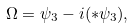Convert formula to latex. <formula><loc_0><loc_0><loc_500><loc_500>\Omega = \psi _ { 3 } - i ( * \psi _ { 3 } ) ,</formula> 